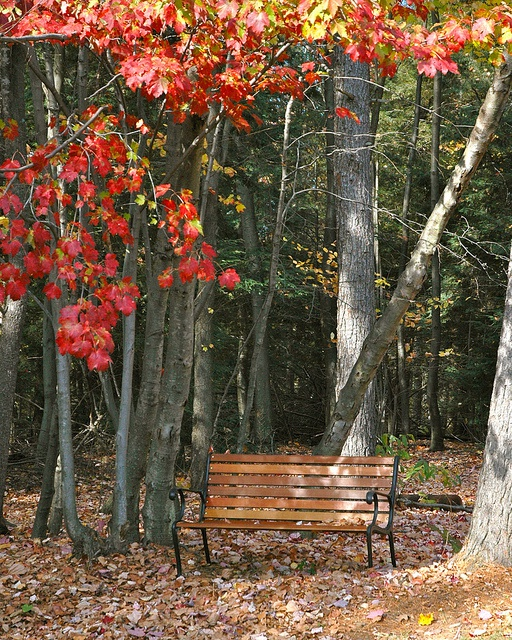Describe the objects in this image and their specific colors. I can see a bench in brown, gray, black, and tan tones in this image. 